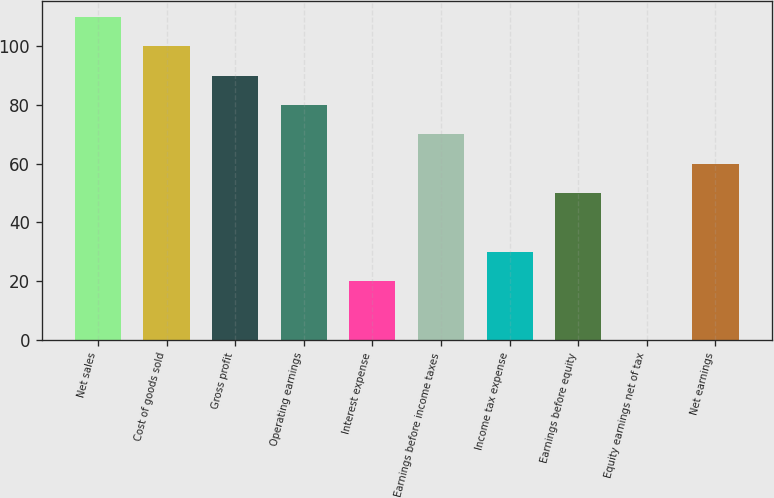Convert chart. <chart><loc_0><loc_0><loc_500><loc_500><bar_chart><fcel>Net sales<fcel>Cost of goods sold<fcel>Gross profit<fcel>Operating earnings<fcel>Interest expense<fcel>Earnings before income taxes<fcel>Income tax expense<fcel>Earnings before equity<fcel>Equity earnings net of tax<fcel>Net earnings<nl><fcel>109.99<fcel>100<fcel>90.01<fcel>80.02<fcel>20.08<fcel>70.03<fcel>30.07<fcel>50.05<fcel>0.1<fcel>60.04<nl></chart> 